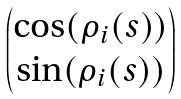Convert formula to latex. <formula><loc_0><loc_0><loc_500><loc_500>\begin{pmatrix} \cos ( \rho _ { i } ( s ) ) \\ \sin ( \rho _ { i } ( s ) ) \end{pmatrix}</formula> 